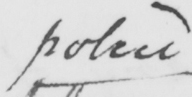Please provide the text content of this handwritten line. police 